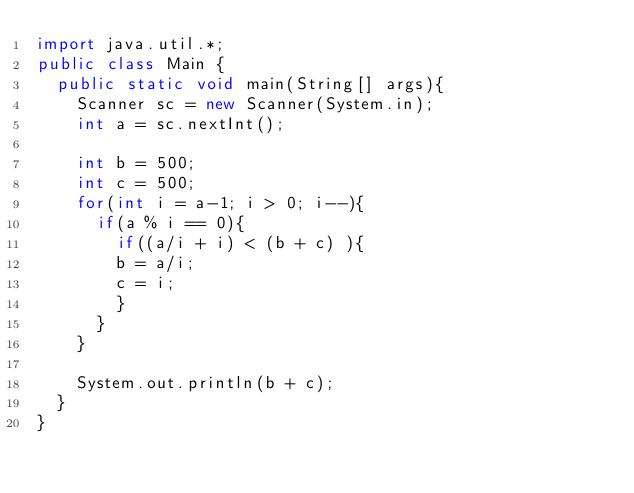<code> <loc_0><loc_0><loc_500><loc_500><_Java_>import java.util.*;
public class Main {
  public static void main(String[] args){
    Scanner sc = new Scanner(System.in);
    int a = sc.nextInt();

    int b = 500;
    int c = 500;
    for(int i = a-1; i > 0; i--){
      if(a % i == 0){
        if((a/i + i) < (b + c) ){
        b = a/i;
        c = i;
        }
      }
    }

    System.out.println(b + c);
  }
}</code> 